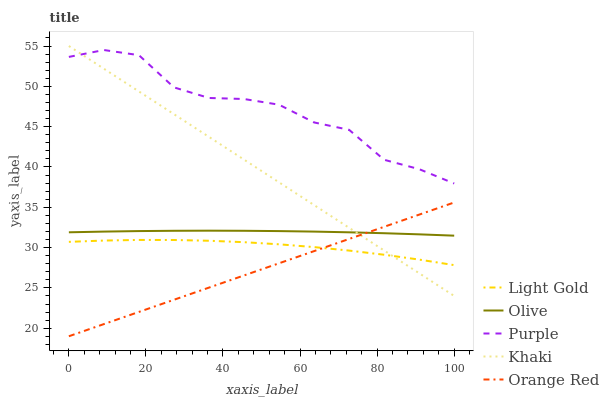Does Orange Red have the minimum area under the curve?
Answer yes or no. Yes. Does Purple have the maximum area under the curve?
Answer yes or no. Yes. Does Khaki have the minimum area under the curve?
Answer yes or no. No. Does Khaki have the maximum area under the curve?
Answer yes or no. No. Is Orange Red the smoothest?
Answer yes or no. Yes. Is Purple the roughest?
Answer yes or no. Yes. Is Khaki the smoothest?
Answer yes or no. No. Is Khaki the roughest?
Answer yes or no. No. Does Orange Red have the lowest value?
Answer yes or no. Yes. Does Khaki have the lowest value?
Answer yes or no. No. Does Khaki have the highest value?
Answer yes or no. Yes. Does Purple have the highest value?
Answer yes or no. No. Is Olive less than Purple?
Answer yes or no. Yes. Is Olive greater than Light Gold?
Answer yes or no. Yes. Does Khaki intersect Orange Red?
Answer yes or no. Yes. Is Khaki less than Orange Red?
Answer yes or no. No. Is Khaki greater than Orange Red?
Answer yes or no. No. Does Olive intersect Purple?
Answer yes or no. No. 